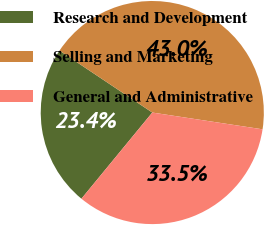Convert chart to OTSL. <chart><loc_0><loc_0><loc_500><loc_500><pie_chart><fcel>Research and Development<fcel>Selling and Marketing<fcel>General and Administrative<nl><fcel>23.42%<fcel>43.03%<fcel>33.55%<nl></chart> 